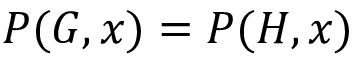Convert formula to latex. <formula><loc_0><loc_0><loc_500><loc_500>P ( G , x ) = P ( H , x )</formula> 